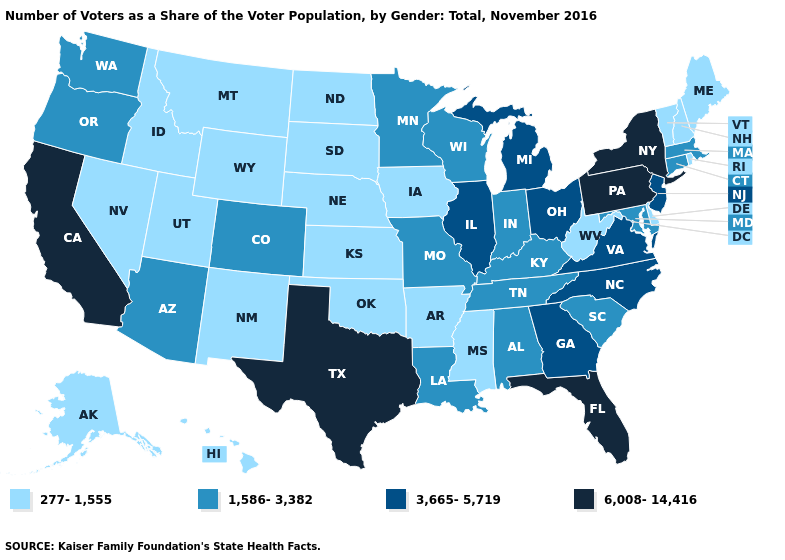How many symbols are there in the legend?
Answer briefly. 4. How many symbols are there in the legend?
Write a very short answer. 4. What is the lowest value in the West?
Quick response, please. 277-1,555. Among the states that border California , which have the highest value?
Be succinct. Arizona, Oregon. Does the map have missing data?
Keep it brief. No. Name the states that have a value in the range 6,008-14,416?
Answer briefly. California, Florida, New York, Pennsylvania, Texas. What is the value of Montana?
Quick response, please. 277-1,555. Name the states that have a value in the range 6,008-14,416?
Answer briefly. California, Florida, New York, Pennsylvania, Texas. Does Minnesota have the same value as Louisiana?
Write a very short answer. Yes. Name the states that have a value in the range 3,665-5,719?
Short answer required. Georgia, Illinois, Michigan, New Jersey, North Carolina, Ohio, Virginia. What is the value of Delaware?
Write a very short answer. 277-1,555. Does Michigan have the highest value in the MidWest?
Be succinct. Yes. Which states hav the highest value in the MidWest?
Short answer required. Illinois, Michigan, Ohio. Does New Jersey have the same value as Hawaii?
Write a very short answer. No. Does Utah have the same value as Arkansas?
Quick response, please. Yes. 